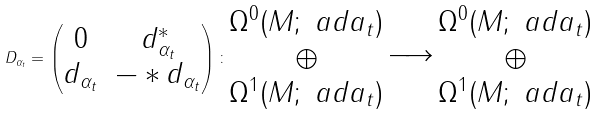<formula> <loc_0><loc_0><loc_500><loc_500>D _ { \alpha _ { t } } = \begin{pmatrix} 0 & d _ { \alpha _ { t } } ^ { * } \\ d _ { \alpha _ { t } } & - * d _ { \alpha _ { t } } \end{pmatrix} \colon \begin{matrix} \Omega ^ { 0 } ( M ; \ a d a _ { t } ) \\ \oplus \\ \Omega ^ { 1 } ( M ; \ a d a _ { t } ) \end{matrix} \xrightarrow { \quad } \begin{matrix} \Omega ^ { 0 } ( M ; \ a d a _ { t } ) \\ \oplus \\ \Omega ^ { 1 } ( M ; \ a d a _ { t } ) \end{matrix}</formula> 